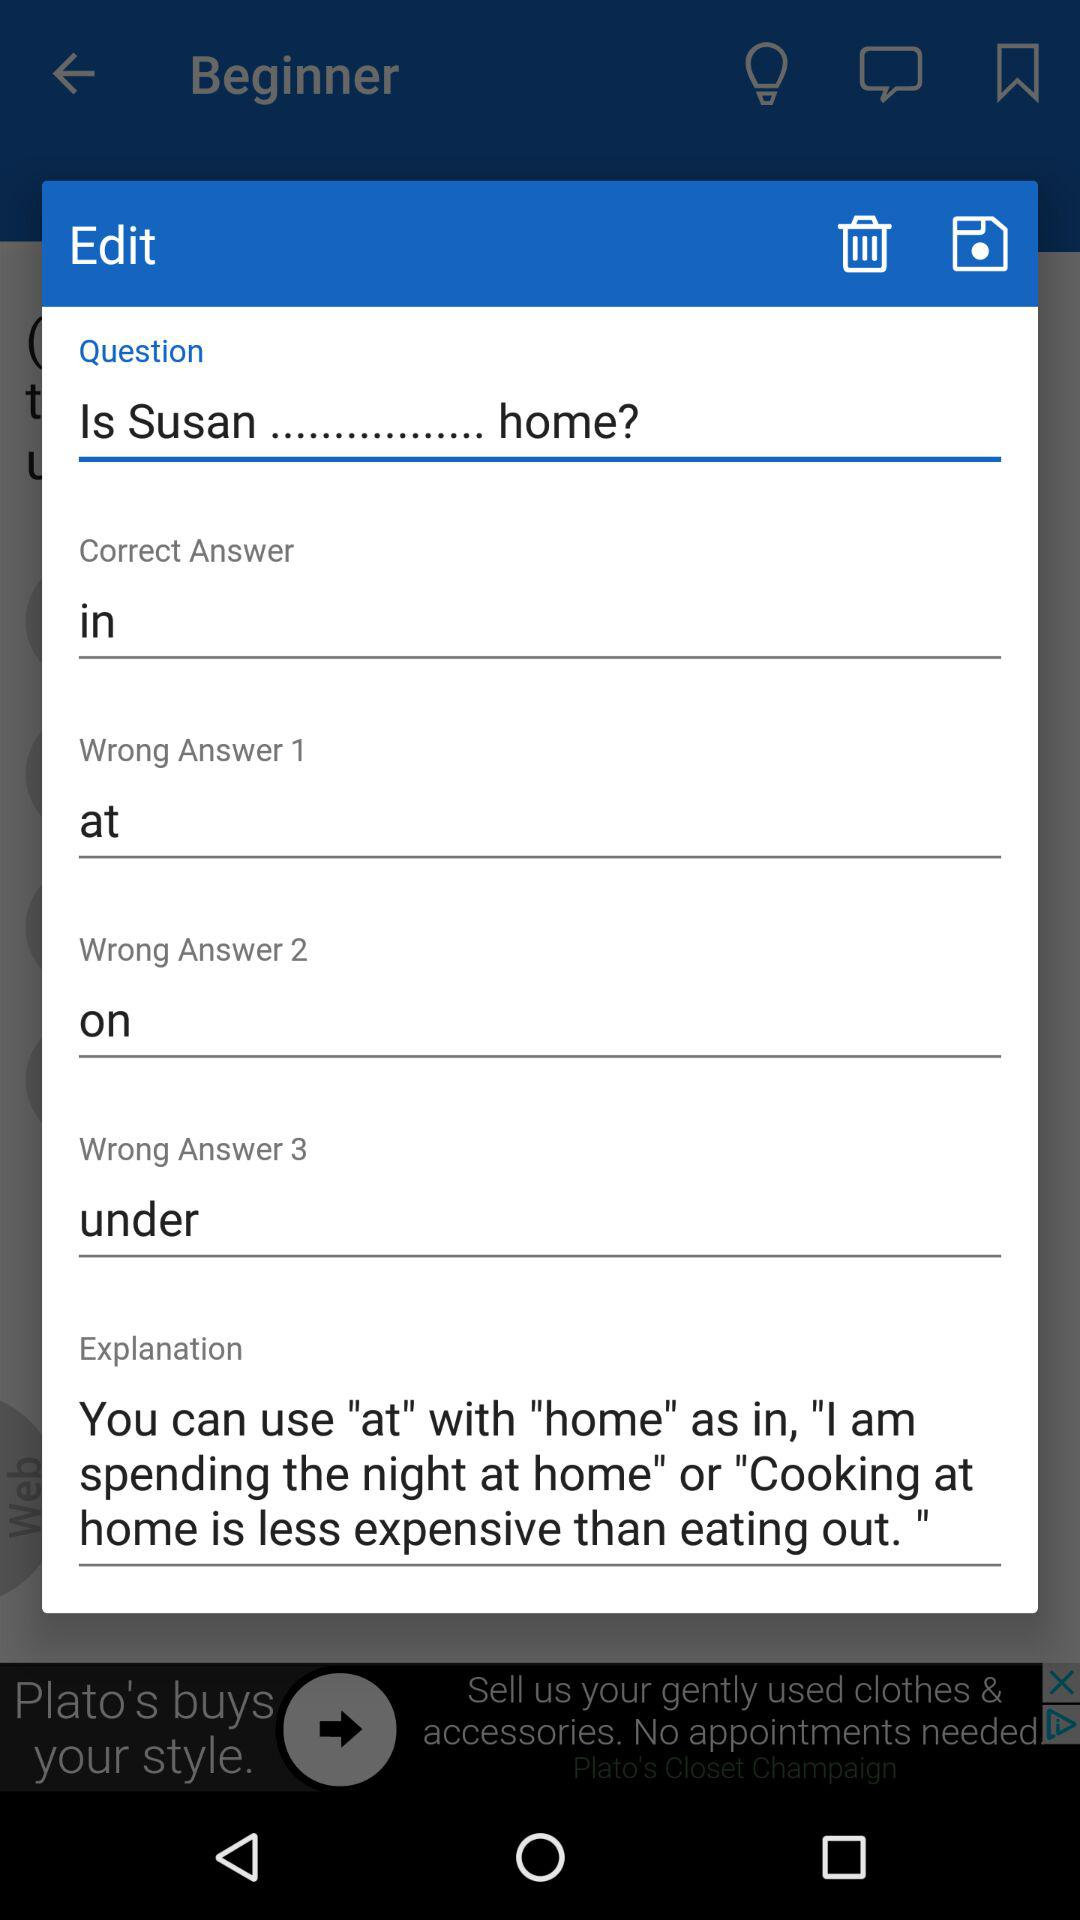What's the wrong answer 1? The Wrong Answer 1 is "at". 